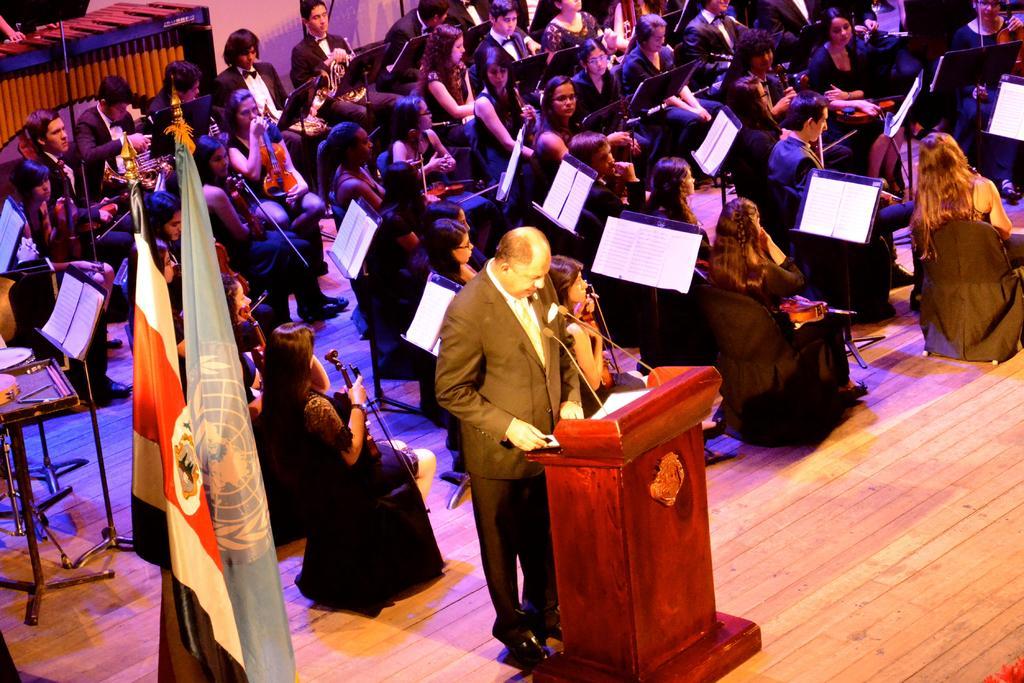Please provide a concise description of this image. In this picture we can see people are sitting on the chairs and they are playing musical instruments. There is a man standing on the floor. Here we can see a podium, mike's, papers, stands, and flags. In the background we can see a wall. 